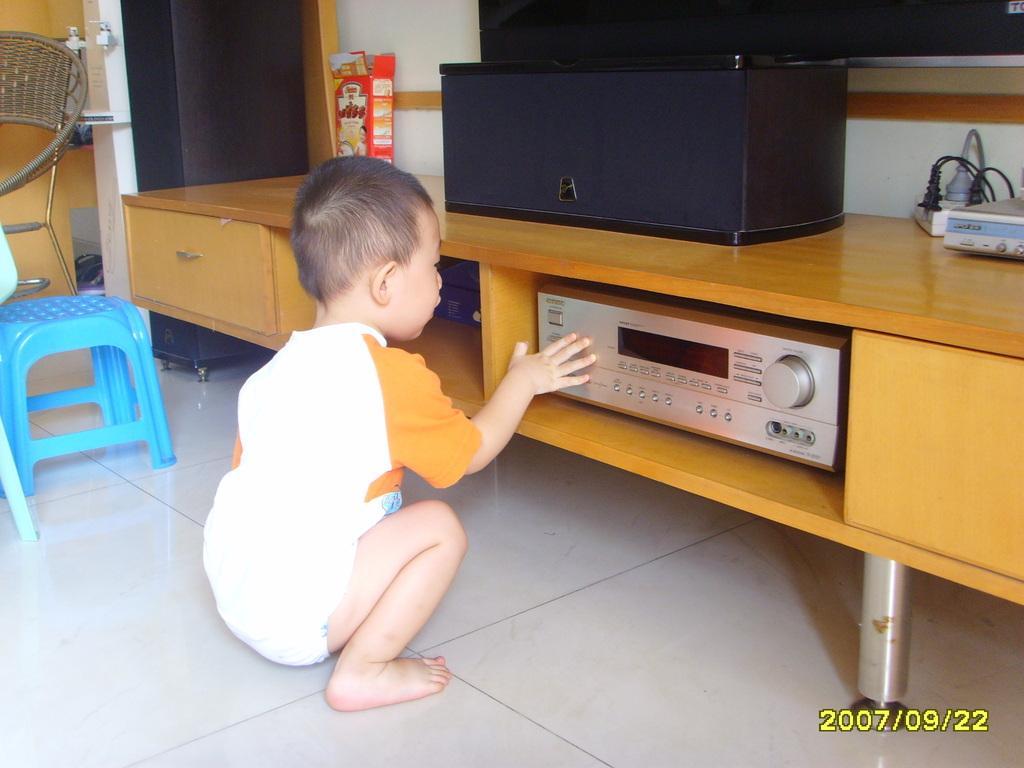Could you give a brief overview of what you see in this image? The kid is touching a music system which is in the table and there is a blue stool beside him. 